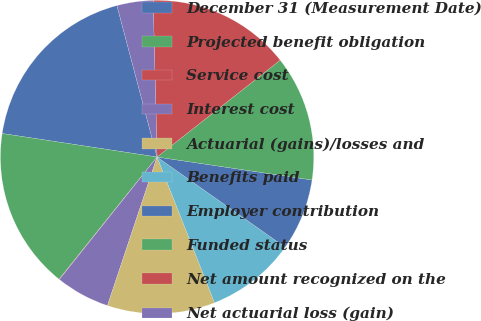Convert chart to OTSL. <chart><loc_0><loc_0><loc_500><loc_500><pie_chart><fcel>December 31 (Measurement Date)<fcel>Projected benefit obligation<fcel>Service cost<fcel>Interest cost<fcel>Actuarial (gains)/losses and<fcel>Benefits paid<fcel>Employer contribution<fcel>Funded status<fcel>Net amount recognized on the<fcel>Net actuarial loss (gain)<nl><fcel>18.48%<fcel>16.64%<fcel>0.05%<fcel>5.58%<fcel>11.11%<fcel>9.26%<fcel>7.42%<fcel>12.95%<fcel>14.79%<fcel>3.73%<nl></chart> 